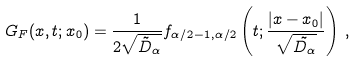Convert formula to latex. <formula><loc_0><loc_0><loc_500><loc_500>G _ { F } ( x , t ; x _ { 0 } ) = \frac { 1 } { 2 \sqrt { \tilde { D } _ { \alpha } } } f _ { \alpha / 2 - 1 , \alpha / 2 } \left ( t ; \frac { | x - x _ { 0 } | } { \sqrt { \tilde { D _ { \alpha } } } } \right ) \, ,</formula> 